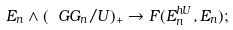<formula> <loc_0><loc_0><loc_500><loc_500>E _ { n } \wedge ( \ G G _ { n } / U ) _ { + } \to F ( E _ { n } ^ { h U } , E _ { n } ) ;</formula> 